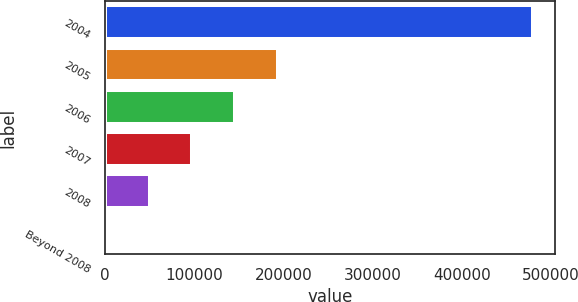<chart> <loc_0><loc_0><loc_500><loc_500><bar_chart><fcel>2004<fcel>2005<fcel>2006<fcel>2007<fcel>2008<fcel>Beyond 2008<nl><fcel>480109<fcel>193617<fcel>145869<fcel>98120.2<fcel>50371.6<fcel>2623<nl></chart> 